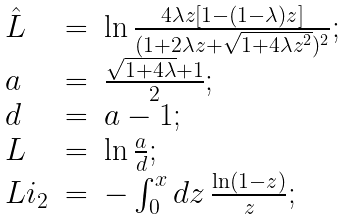Convert formula to latex. <formula><loc_0><loc_0><loc_500><loc_500>\begin{array} { l l l } { { \hat { L } } } & { = } & { { \ln \frac { 4 \lambda z [ 1 - ( 1 - \lambda ) z ] } { ( 1 + 2 \lambda z + \sqrt { 1 + 4 \lambda z ^ { 2 } } ) ^ { 2 } } ; } } \\ { a } & { = } & { { \frac { \sqrt { 1 + 4 \lambda } + 1 } { 2 } ; } } \\ { d } & { = } & { a - 1 ; } \\ { L } & { = } & { { \ln \frac { a } { d } ; } } \\ { { L i _ { 2 } } } & { = } & { { - \int _ { 0 } ^ { x } { d z \, \frac { \ln ( 1 - z ) } { z } } ; } } \end{array}</formula> 